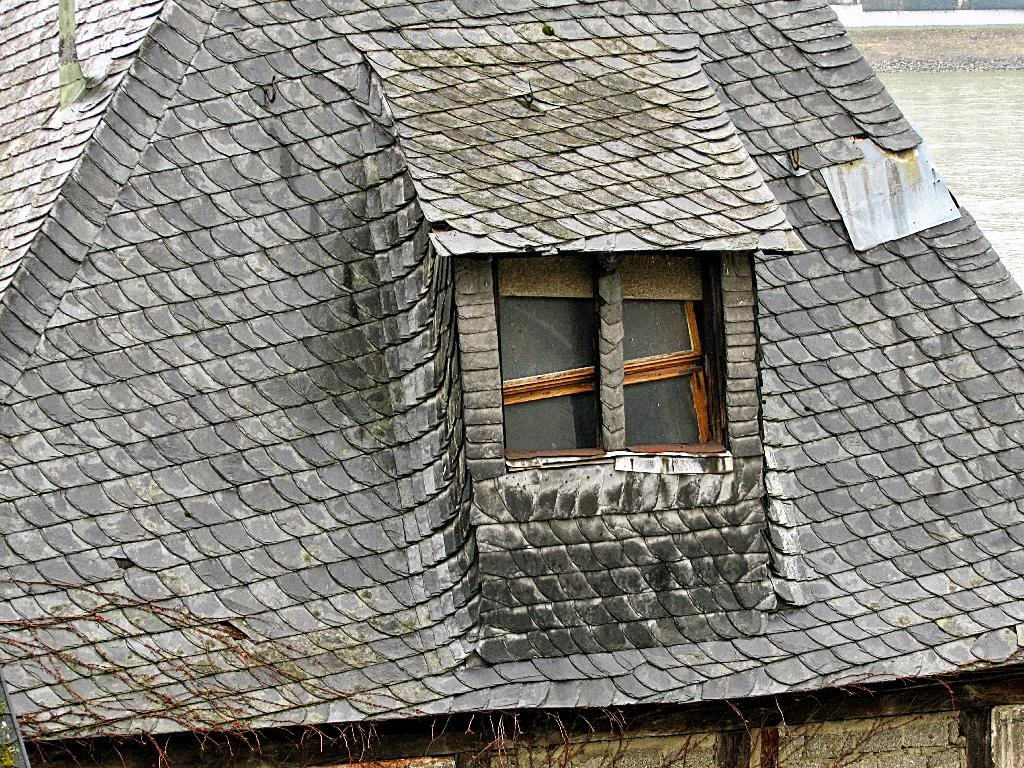What part of a building can be seen in the image? There is a roof of a building in the image. What architectural feature is visible on the building? There is a window visible in the image. What can be seen in the background of the image? There is water visible in the background of the image. How many guitars are being played by the babies in the image? There are no guitars or babies present in the image. 